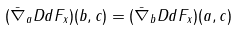Convert formula to latex. <formula><loc_0><loc_0><loc_500><loc_500>( \bar { \nabla } _ { a } D d F _ { x } ) ( b , c ) = ( \bar { \nabla } _ { b } D d F _ { x } ) ( a , c )</formula> 